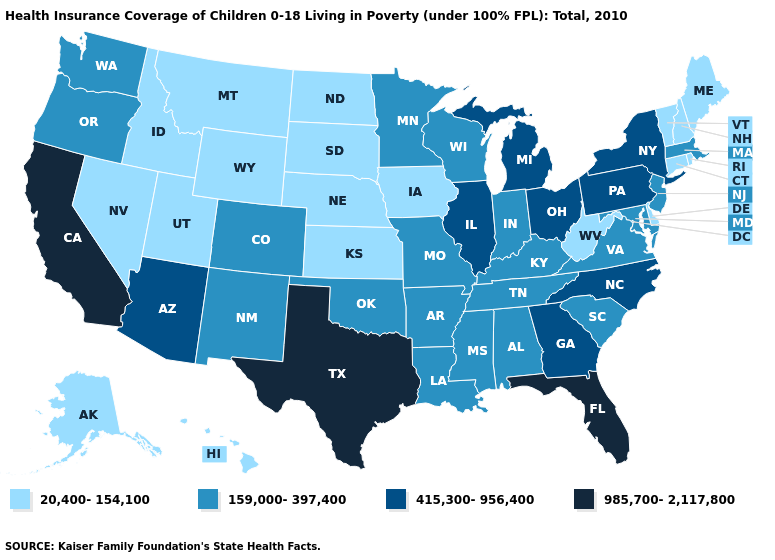What is the value of North Carolina?
Write a very short answer. 415,300-956,400. Which states have the highest value in the USA?
Answer briefly. California, Florida, Texas. Name the states that have a value in the range 159,000-397,400?
Give a very brief answer. Alabama, Arkansas, Colorado, Indiana, Kentucky, Louisiana, Maryland, Massachusetts, Minnesota, Mississippi, Missouri, New Jersey, New Mexico, Oklahoma, Oregon, South Carolina, Tennessee, Virginia, Washington, Wisconsin. Name the states that have a value in the range 415,300-956,400?
Be succinct. Arizona, Georgia, Illinois, Michigan, New York, North Carolina, Ohio, Pennsylvania. What is the value of Arkansas?
Quick response, please. 159,000-397,400. What is the value of South Dakota?
Concise answer only. 20,400-154,100. Name the states that have a value in the range 159,000-397,400?
Answer briefly. Alabama, Arkansas, Colorado, Indiana, Kentucky, Louisiana, Maryland, Massachusetts, Minnesota, Mississippi, Missouri, New Jersey, New Mexico, Oklahoma, Oregon, South Carolina, Tennessee, Virginia, Washington, Wisconsin. Does Hawaii have the lowest value in the USA?
Concise answer only. Yes. What is the highest value in the MidWest ?
Concise answer only. 415,300-956,400. Name the states that have a value in the range 159,000-397,400?
Keep it brief. Alabama, Arkansas, Colorado, Indiana, Kentucky, Louisiana, Maryland, Massachusetts, Minnesota, Mississippi, Missouri, New Jersey, New Mexico, Oklahoma, Oregon, South Carolina, Tennessee, Virginia, Washington, Wisconsin. What is the value of Illinois?
Keep it brief. 415,300-956,400. What is the value of Wyoming?
Give a very brief answer. 20,400-154,100. Does Tennessee have a higher value than North Carolina?
Quick response, please. No. Name the states that have a value in the range 20,400-154,100?
Write a very short answer. Alaska, Connecticut, Delaware, Hawaii, Idaho, Iowa, Kansas, Maine, Montana, Nebraska, Nevada, New Hampshire, North Dakota, Rhode Island, South Dakota, Utah, Vermont, West Virginia, Wyoming. Among the states that border Iowa , does Illinois have the highest value?
Keep it brief. Yes. 